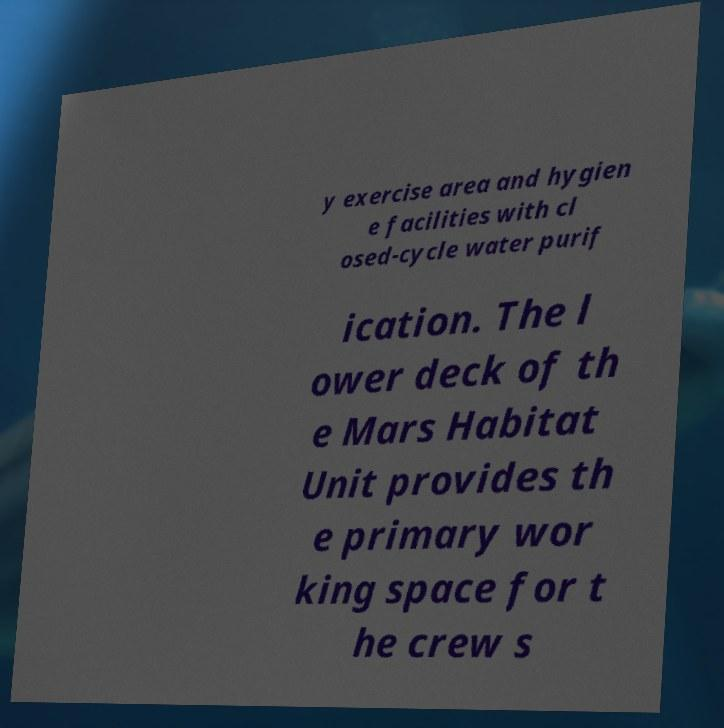For documentation purposes, I need the text within this image transcribed. Could you provide that? y exercise area and hygien e facilities with cl osed-cycle water purif ication. The l ower deck of th e Mars Habitat Unit provides th e primary wor king space for t he crew s 